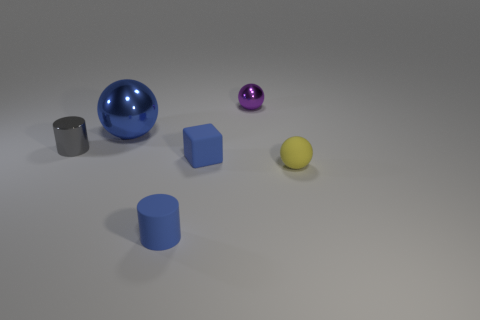Are any big cyan cubes visible?
Keep it short and to the point. No. Is the material of the blue block the same as the purple sphere on the right side of the tiny blue block?
Your answer should be compact. No. There is a yellow object that is the same size as the blue block; what is it made of?
Provide a succinct answer. Rubber. Are there any other purple things that have the same material as the big object?
Provide a short and direct response. Yes. Are there any small gray cylinders that are in front of the small sphere that is on the right side of the small metal thing that is right of the gray metal cylinder?
Offer a terse response. No. There is a gray object that is the same size as the matte cylinder; what is its shape?
Ensure brevity in your answer.  Cylinder. Does the metallic ball left of the purple metallic ball have the same size as the cylinder that is in front of the tiny gray thing?
Offer a terse response. No. How many small green rubber balls are there?
Your response must be concise. 0. There is a metal sphere left of the rubber thing in front of the tiny ball that is in front of the large shiny ball; what is its size?
Keep it short and to the point. Large. Is the color of the small block the same as the tiny shiny sphere?
Provide a succinct answer. No. 